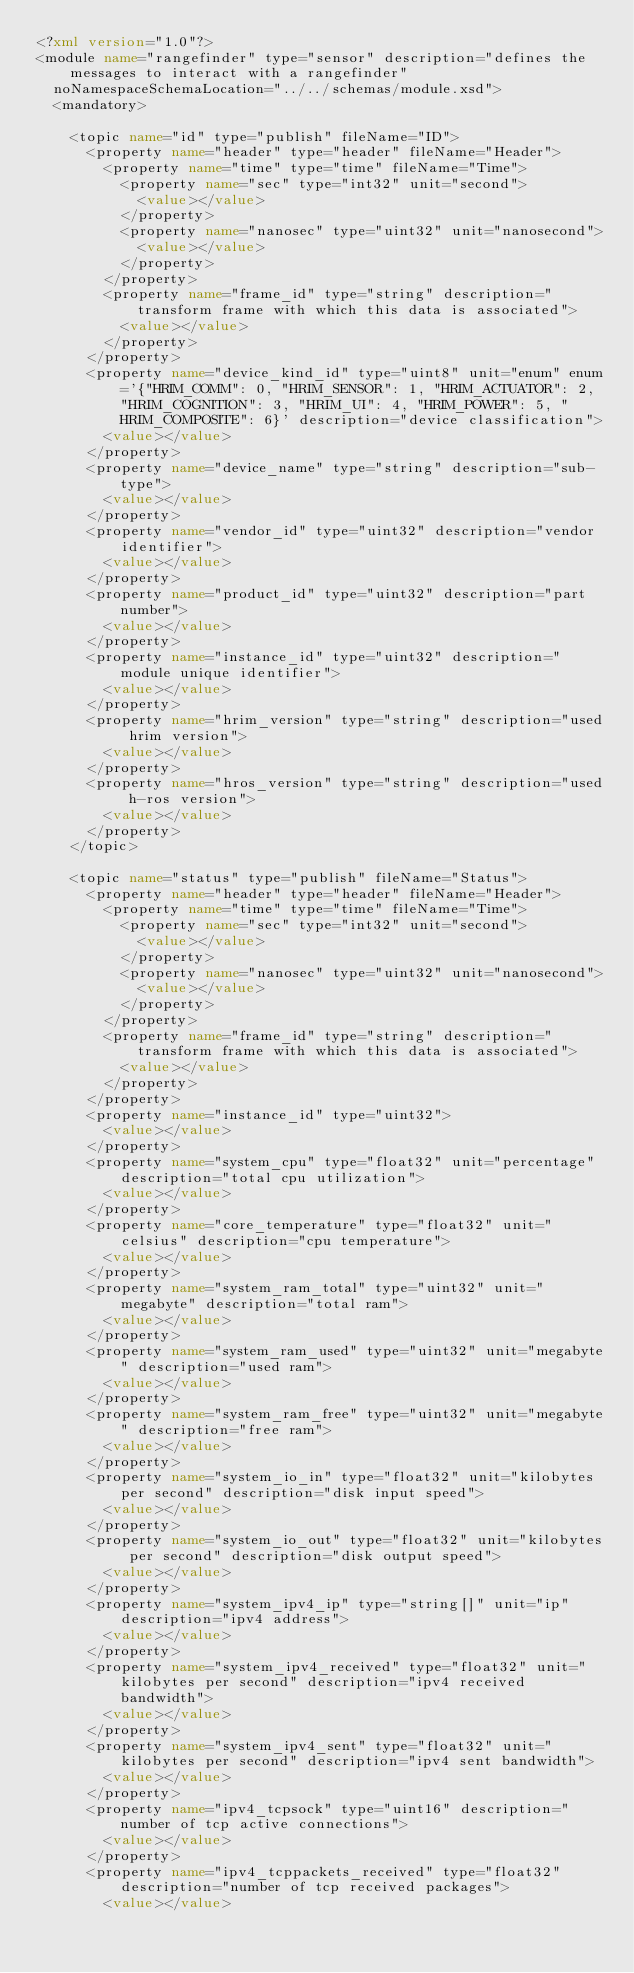<code> <loc_0><loc_0><loc_500><loc_500><_XML_><?xml version="1.0"?>
<module name="rangefinder" type="sensor" description="defines the messages to interact with a rangefinder"
  noNamespaceSchemaLocation="../../schemas/module.xsd">
  <mandatory>

    <topic name="id" type="publish" fileName="ID">
      <property name="header" type="header" fileName="Header">
        <property name="time" type="time" fileName="Time">
          <property name="sec" type="int32" unit="second">
            <value></value>
          </property>
          <property name="nanosec" type="uint32" unit="nanosecond">
            <value></value>
          </property>
        </property>
        <property name="frame_id" type="string" description="transform frame with which this data is associated">
          <value></value>
        </property>
      </property>
      <property name="device_kind_id" type="uint8" unit="enum" enum='{"HRIM_COMM": 0, "HRIM_SENSOR": 1, "HRIM_ACTUATOR": 2, "HRIM_COGNITION": 3, "HRIM_UI": 4, "HRIM_POWER": 5, "HRIM_COMPOSITE": 6}' description="device classification">
        <value></value>
      </property>
      <property name="device_name" type="string" description="sub-type">
        <value></value>
      </property>
      <property name="vendor_id" type="uint32" description="vendor identifier">
        <value></value>
      </property>
      <property name="product_id" type="uint32" description="part number">
        <value></value>
      </property>
      <property name="instance_id" type="uint32" description="module unique identifier">
        <value></value>
      </property>
      <property name="hrim_version" type="string" description="used hrim version">
        <value></value>
      </property>
      <property name="hros_version" type="string" description="used h-ros version">
        <value></value>
      </property>
    </topic>

    <topic name="status" type="publish" fileName="Status">
      <property name="header" type="header" fileName="Header">
        <property name="time" type="time" fileName="Time">
          <property name="sec" type="int32" unit="second">
            <value></value>
          </property>
          <property name="nanosec" type="uint32" unit="nanosecond">
            <value></value>
          </property>
        </property>
        <property name="frame_id" type="string" description="transform frame with which this data is associated">
          <value></value>
        </property>
      </property>
      <property name="instance_id" type="uint32">
        <value></value>
      </property>
      <property name="system_cpu" type="float32" unit="percentage" description="total cpu utilization">
        <value></value>
      </property>
      <property name="core_temperature" type="float32" unit="celsius" description="cpu temperature">
        <value></value>
      </property>
      <property name="system_ram_total" type="uint32" unit="megabyte" description="total ram">
        <value></value>
      </property>
      <property name="system_ram_used" type="uint32" unit="megabyte" description="used ram">
        <value></value>
      </property>
      <property name="system_ram_free" type="uint32" unit="megabyte" description="free ram">
        <value></value>
      </property>
      <property name="system_io_in" type="float32" unit="kilobytes per second" description="disk input speed">
        <value></value>
      </property>
      <property name="system_io_out" type="float32" unit="kilobytes per second" description="disk output speed">
        <value></value>
      </property>
      <property name="system_ipv4_ip" type="string[]" unit="ip" description="ipv4 address">
        <value></value>
      </property>
      <property name="system_ipv4_received" type="float32" unit="kilobytes per second" description="ipv4 received bandwidth">
        <value></value>
      </property>
      <property name="system_ipv4_sent" type="float32" unit="kilobytes per second" description="ipv4 sent bandwidth">
        <value></value>
      </property>
      <property name="ipv4_tcpsock" type="uint16" description="number of tcp active connections">
        <value></value>
      </property>
      <property name="ipv4_tcppackets_received" type="float32" description="number of tcp received packages">
        <value></value></code> 